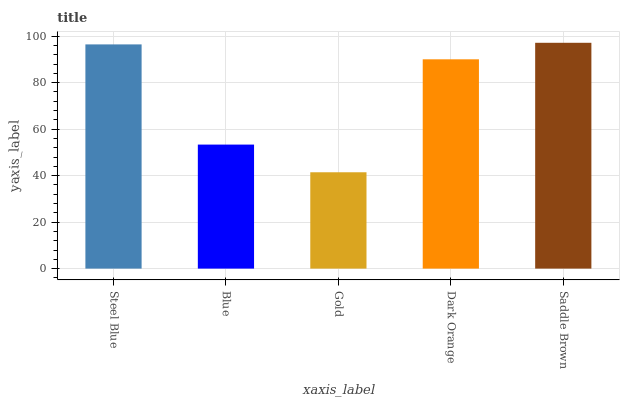Is Gold the minimum?
Answer yes or no. Yes. Is Saddle Brown the maximum?
Answer yes or no. Yes. Is Blue the minimum?
Answer yes or no. No. Is Blue the maximum?
Answer yes or no. No. Is Steel Blue greater than Blue?
Answer yes or no. Yes. Is Blue less than Steel Blue?
Answer yes or no. Yes. Is Blue greater than Steel Blue?
Answer yes or no. No. Is Steel Blue less than Blue?
Answer yes or no. No. Is Dark Orange the high median?
Answer yes or no. Yes. Is Dark Orange the low median?
Answer yes or no. Yes. Is Gold the high median?
Answer yes or no. No. Is Steel Blue the low median?
Answer yes or no. No. 